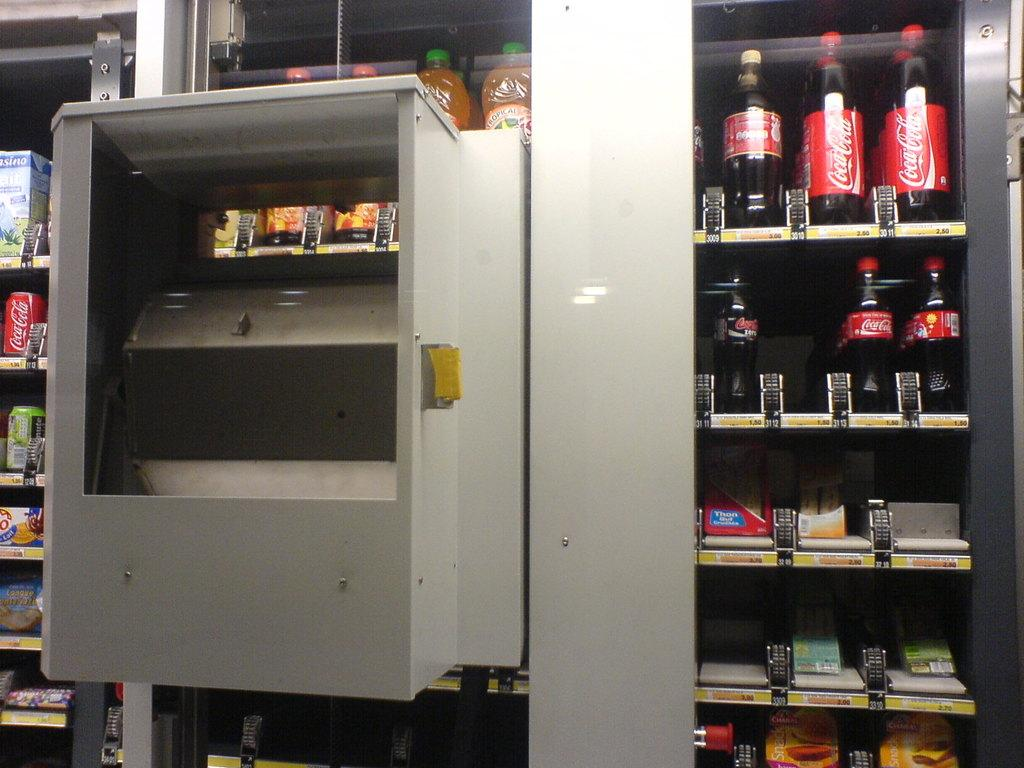<image>
Present a compact description of the photo's key features. A vending machine which includes drinks and snacks including several bottles of Coca-Cola 